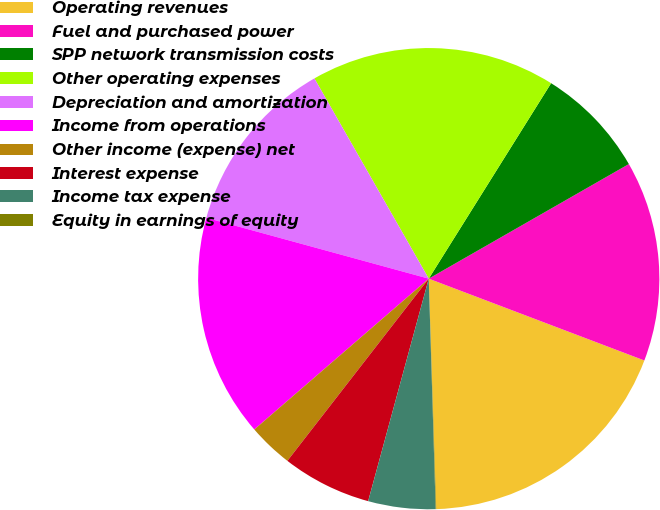<chart> <loc_0><loc_0><loc_500><loc_500><pie_chart><fcel>Operating revenues<fcel>Fuel and purchased power<fcel>SPP network transmission costs<fcel>Other operating expenses<fcel>Depreciation and amortization<fcel>Income from operations<fcel>Other income (expense) net<fcel>Interest expense<fcel>Income tax expense<fcel>Equity in earnings of equity<nl><fcel>18.71%<fcel>14.05%<fcel>7.82%<fcel>17.16%<fcel>12.49%<fcel>15.6%<fcel>3.15%<fcel>6.27%<fcel>4.71%<fcel>0.04%<nl></chart> 